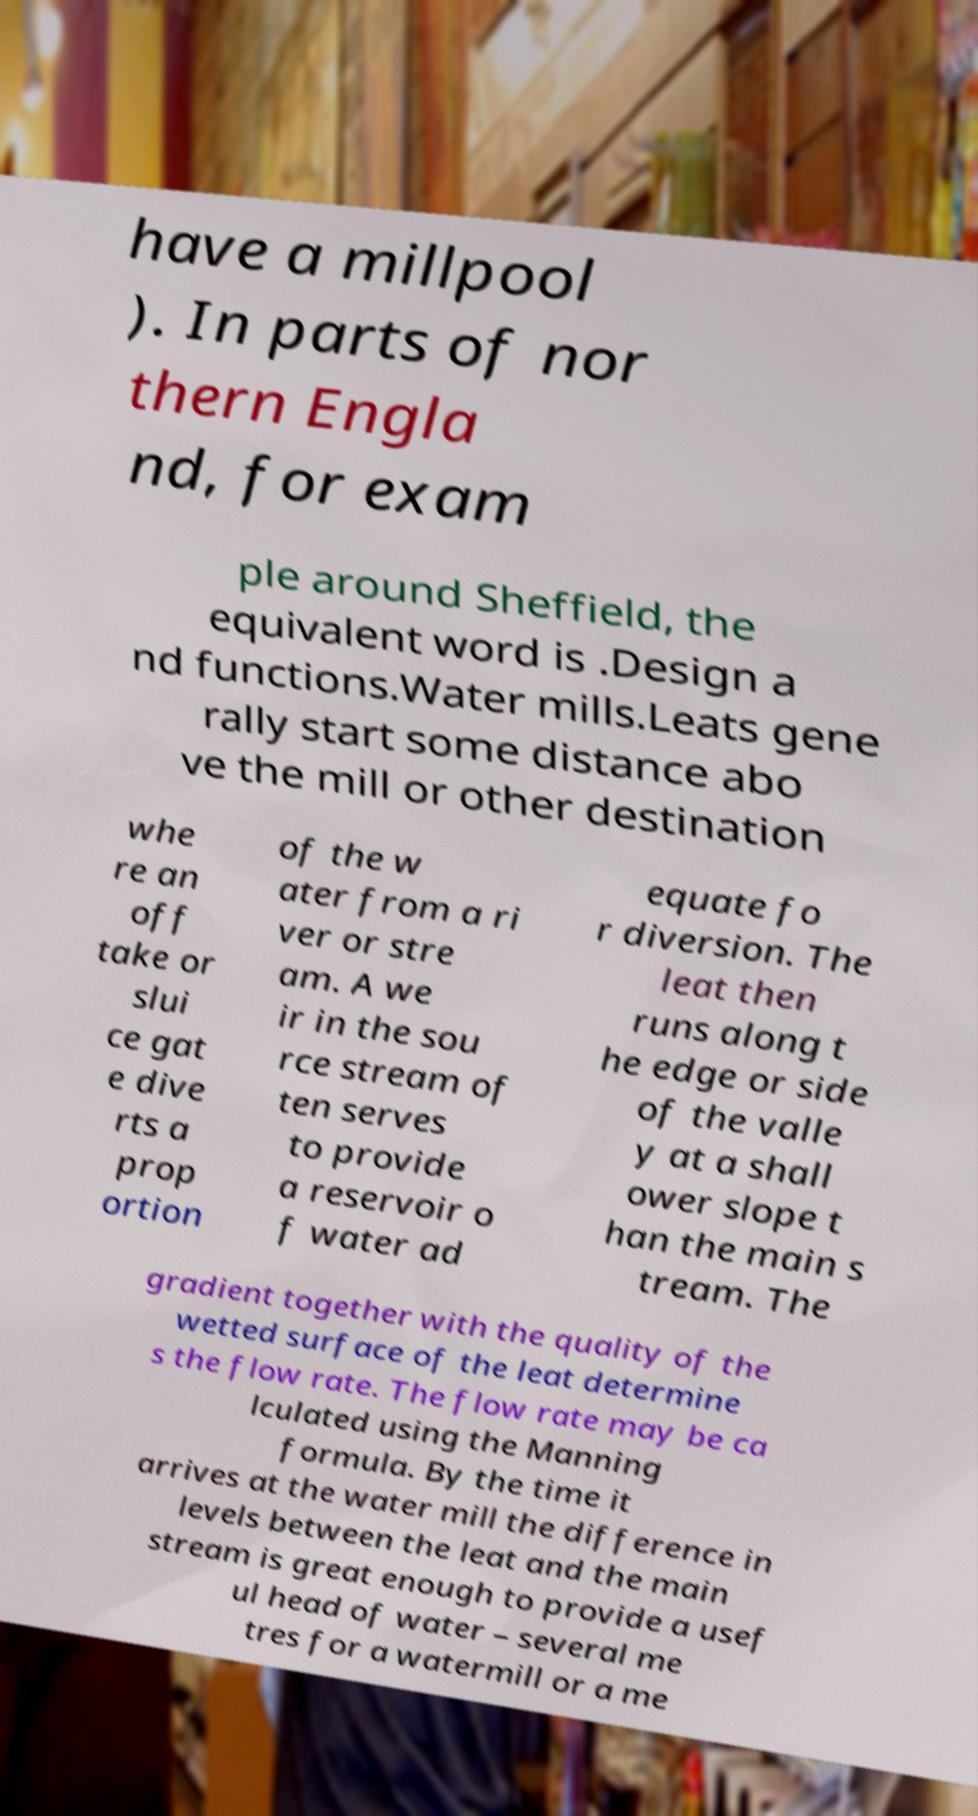Could you extract and type out the text from this image? have a millpool ). In parts of nor thern Engla nd, for exam ple around Sheffield, the equivalent word is .Design a nd functions.Water mills.Leats gene rally start some distance abo ve the mill or other destination whe re an off take or slui ce gat e dive rts a prop ortion of the w ater from a ri ver or stre am. A we ir in the sou rce stream of ten serves to provide a reservoir o f water ad equate fo r diversion. The leat then runs along t he edge or side of the valle y at a shall ower slope t han the main s tream. The gradient together with the quality of the wetted surface of the leat determine s the flow rate. The flow rate may be ca lculated using the Manning formula. By the time it arrives at the water mill the difference in levels between the leat and the main stream is great enough to provide a usef ul head of water – several me tres for a watermill or a me 